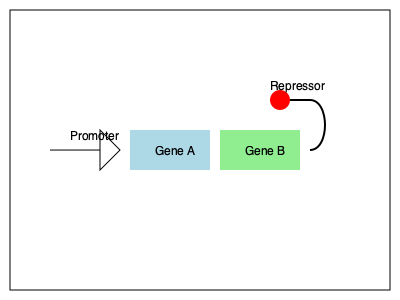In the genetic circuit shown above, Gene A produces a protein that activates the expression of Gene B. The product of Gene B acts as a repressor for the promoter of Gene A. If we introduce an external stimulus that increases the degradation rate of the repressor protein, how would this affect the expression levels of Gene A and Gene B over time? To understand the effect of increased repressor degradation on gene expression, let's break down the process step-by-step:

1. Initial state:
   - Gene A is expressed, producing its protein product.
   - The protein product of Gene A activates Gene B.
   - Gene B produces a repressor protein that inhibits Gene A's promoter.

2. Introduction of the external stimulus:
   - The degradation rate of the repressor protein (product of Gene B) increases.

3. Immediate effects:
   - The concentration of the repressor protein decreases due to increased degradation.
   - This leads to reduced repression of Gene A's promoter.

4. Gene A expression:
   - With less repression, Gene A's expression increases.
   - More of Gene A's protein product is produced.

5. Gene B expression:
   - The increased concentration of Gene A's protein product leads to higher activation of Gene B.
   - Gene B's expression increases, producing more repressor protein.

6. Feedback loop:
   - The increased production of repressor protein counteracts its increased degradation.
   - This creates a new equilibrium with higher expression levels of both genes.

7. Oscillatory behavior:
   - Depending on the kinetics of protein production and degradation, the system may exhibit oscillatory behavior.
   - Gene A and B expression levels may fluctuate before settling into a new steady state.

8. New steady state:
   - Both Gene A and Gene B will likely have higher expression levels in the new steady state compared to the initial state.
   - The exact levels will depend on the balance between increased repressor degradation and increased gene expression.
Answer: Increased expression of both Gene A and Gene B, potentially with oscillatory behavior before reaching a new steady state. 